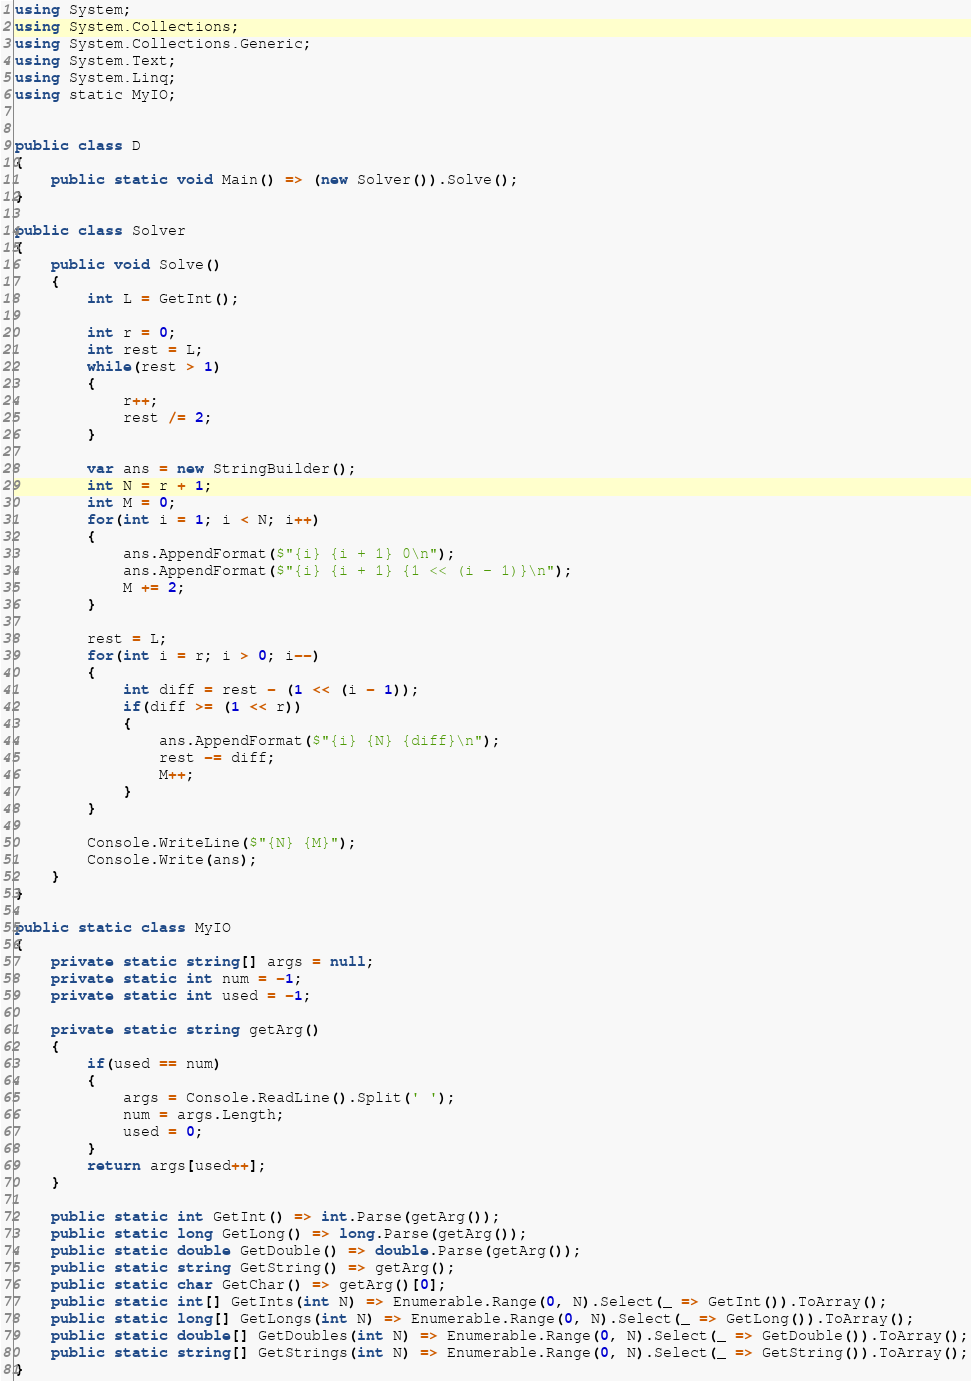<code> <loc_0><loc_0><loc_500><loc_500><_C#_>using System;
using System.Collections;
using System.Collections.Generic;
using System.Text;
using System.Linq;
using static MyIO;


public class D
{
	public static void Main() => (new Solver()).Solve();
}

public class Solver
{
	public void Solve()
	{
		int L = GetInt();

		int r = 0;
		int rest = L;
		while(rest > 1)
		{
			r++;
			rest /= 2;
		}

		var ans = new StringBuilder();
		int N = r + 1;
		int M = 0;
		for(int i = 1; i < N; i++)
		{
			ans.AppendFormat($"{i} {i + 1} 0\n");
			ans.AppendFormat($"{i} {i + 1} {1 << (i - 1)}\n");
			M += 2;
		}

		rest = L;
		for(int i = r; i > 0; i--)
		{
			int diff = rest - (1 << (i - 1));
			if(diff >= (1 << r))
			{
				ans.AppendFormat($"{i} {N} {diff}\n");
				rest -= diff;
				M++;
			}
		}

		Console.WriteLine($"{N} {M}");
		Console.Write(ans);
	}
}

public static class MyIO
{
	private static string[] args = null;
	private static int num = -1;
	private static int used = -1;

	private static string getArg()
	{
		if(used == num)
		{
			args = Console.ReadLine().Split(' ');
			num = args.Length;
			used = 0;
		}
		return args[used++];
	}

	public static int GetInt() => int.Parse(getArg());
	public static long GetLong() => long.Parse(getArg());
	public static double GetDouble() => double.Parse(getArg());
	public static string GetString() => getArg();
	public static char GetChar() => getArg()[0];
	public static int[] GetInts(int N) => Enumerable.Range(0, N).Select(_ => GetInt()).ToArray();
	public static long[] GetLongs(int N) => Enumerable.Range(0, N).Select(_ => GetLong()).ToArray();
	public static double[] GetDoubles(int N) => Enumerable.Range(0, N).Select(_ => GetDouble()).ToArray();
	public static string[] GetStrings(int N) => Enumerable.Range(0, N).Select(_ => GetString()).ToArray();
}
</code> 